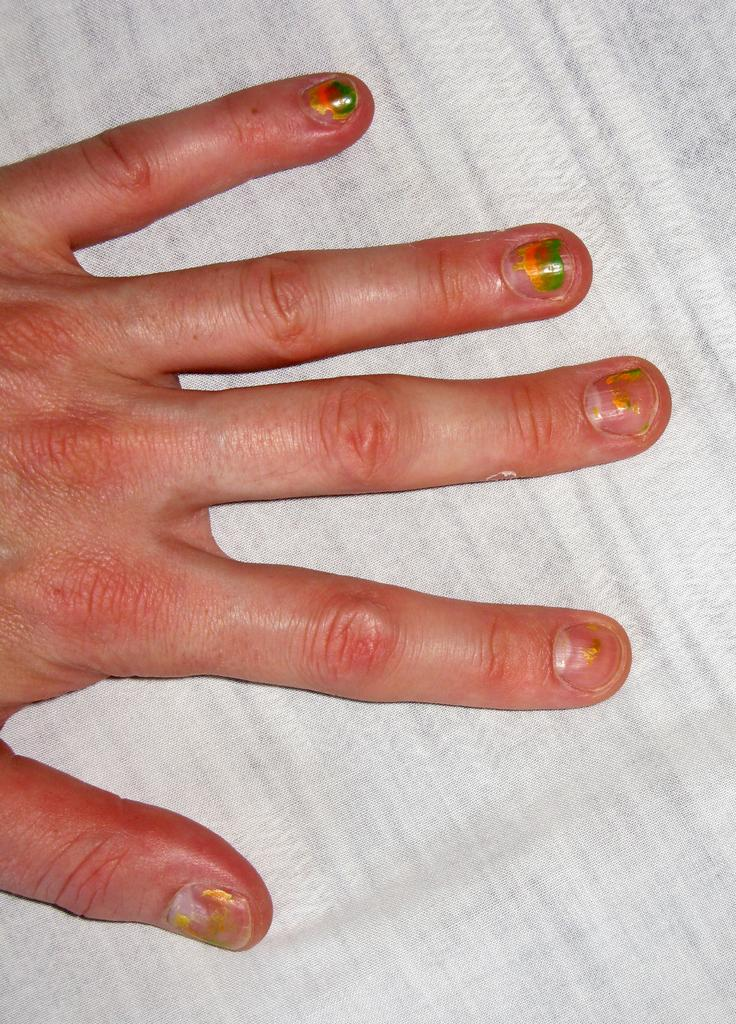What part of a person's body is visible in the image? There is a person's hand in the image. Where is the hand located? The hand is on a bed. Can you describe the setting of the image? The image is likely taken in a room, as it features a bed. What shape is the loaf of bread on the bed in the image? There is no loaf of bread present in the image; it only features a person's hand on a bed. 